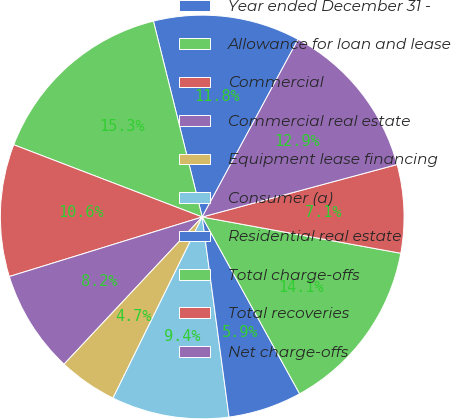Convert chart to OTSL. <chart><loc_0><loc_0><loc_500><loc_500><pie_chart><fcel>Year ended December 31 -<fcel>Allowance for loan and lease<fcel>Commercial<fcel>Commercial real estate<fcel>Equipment lease financing<fcel>Consumer (a)<fcel>Residential real estate<fcel>Total charge-offs<fcel>Total recoveries<fcel>Net charge-offs<nl><fcel>11.76%<fcel>15.29%<fcel>10.59%<fcel>8.24%<fcel>4.71%<fcel>9.41%<fcel>5.89%<fcel>14.11%<fcel>7.06%<fcel>12.94%<nl></chart> 